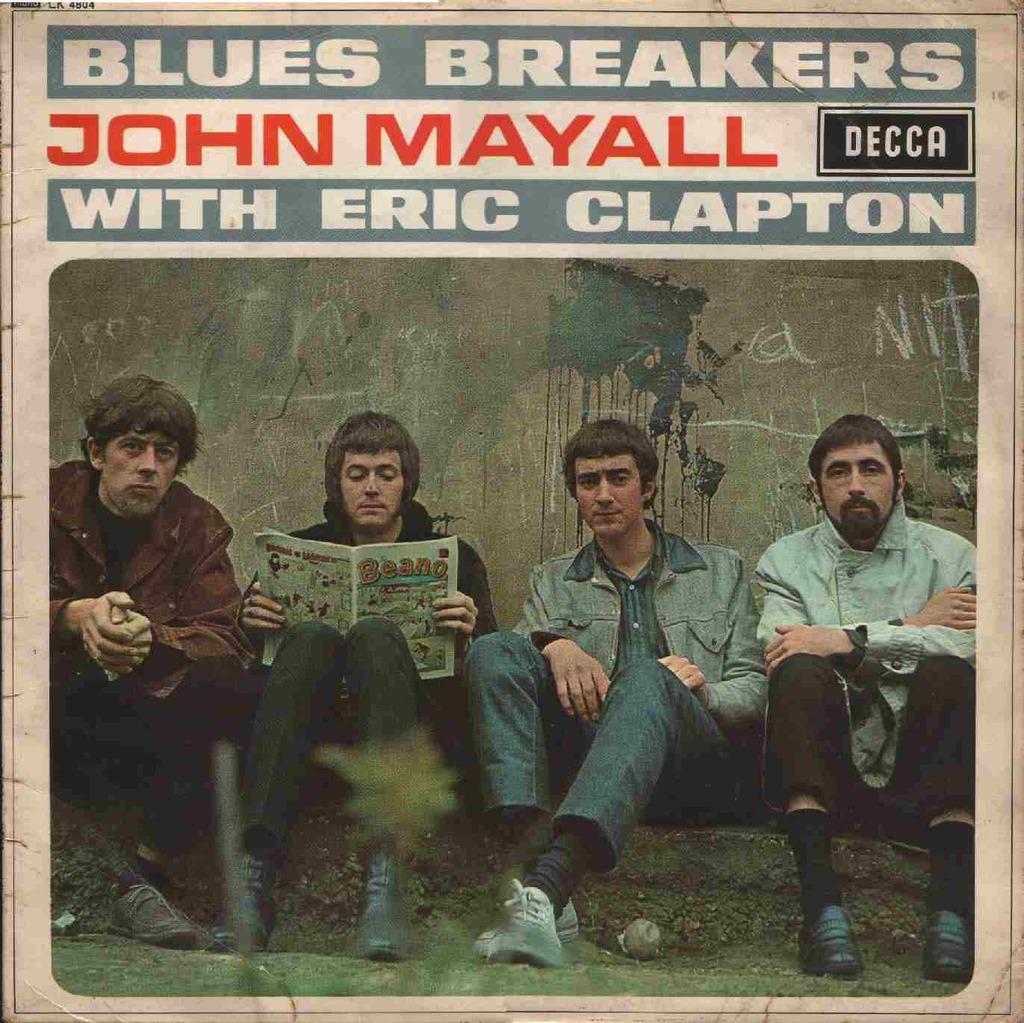In one or two sentences, can you explain what this image depicts? In this image we can see a poster with text and an image of persons sitting on the ground and a person is holding a book and a wall behind them. 